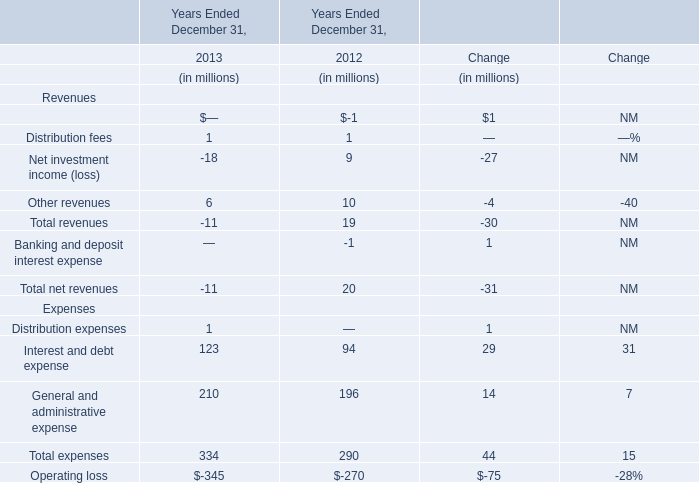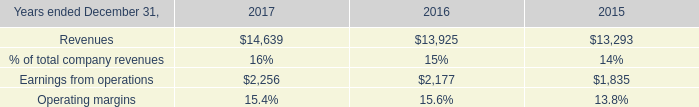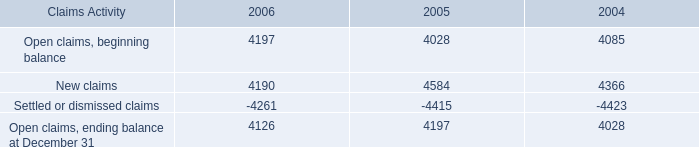What's the growth rate of Interest and debt expense in 2013? 
Computations: ((123 - 94) / 94)
Answer: 0.30851. 